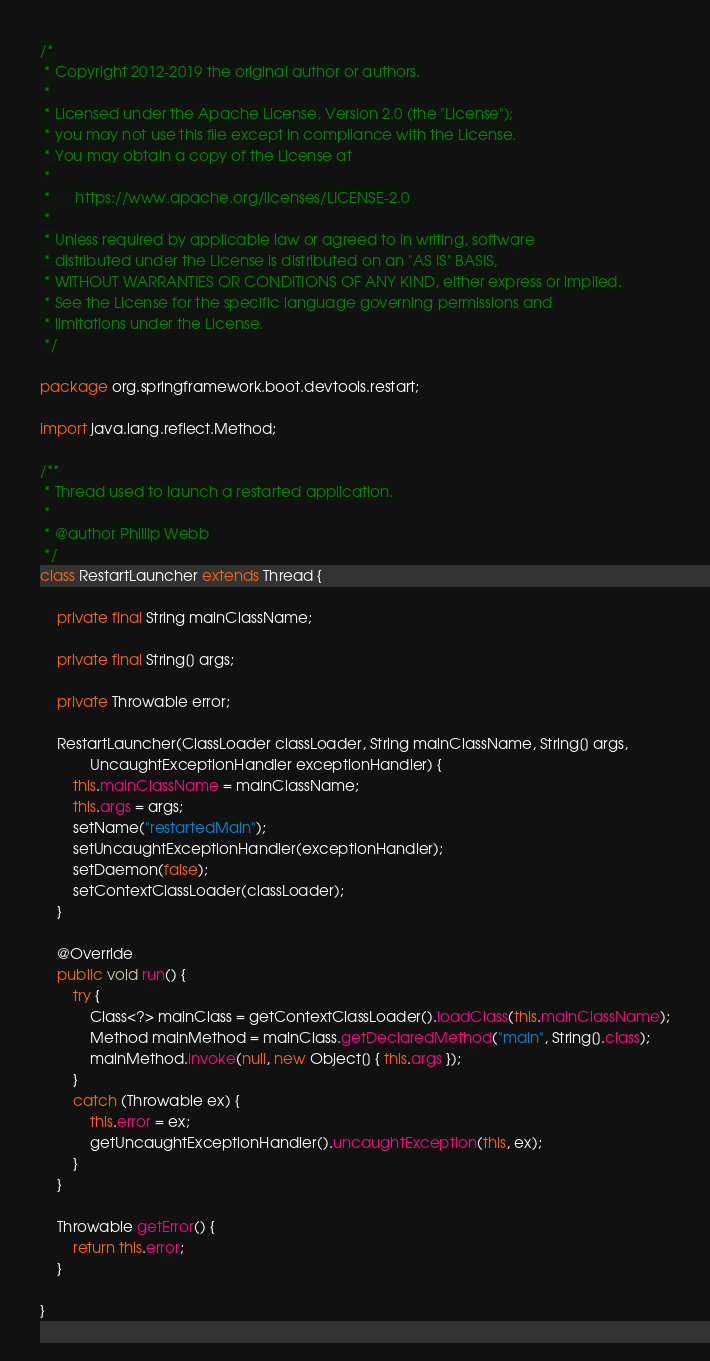<code> <loc_0><loc_0><loc_500><loc_500><_Java_>/*
 * Copyright 2012-2019 the original author or authors.
 *
 * Licensed under the Apache License, Version 2.0 (the "License");
 * you may not use this file except in compliance with the License.
 * You may obtain a copy of the License at
 *
 *      https://www.apache.org/licenses/LICENSE-2.0
 *
 * Unless required by applicable law or agreed to in writing, software
 * distributed under the License is distributed on an "AS IS" BASIS,
 * WITHOUT WARRANTIES OR CONDITIONS OF ANY KIND, either express or implied.
 * See the License for the specific language governing permissions and
 * limitations under the License.
 */

package org.springframework.boot.devtools.restart;

import java.lang.reflect.Method;

/**
 * Thread used to launch a restarted application.
 *
 * @author Phillip Webb
 */
class RestartLauncher extends Thread {

	private final String mainClassName;

	private final String[] args;

	private Throwable error;

	RestartLauncher(ClassLoader classLoader, String mainClassName, String[] args,
			UncaughtExceptionHandler exceptionHandler) {
		this.mainClassName = mainClassName;
		this.args = args;
		setName("restartedMain");
		setUncaughtExceptionHandler(exceptionHandler);
		setDaemon(false);
		setContextClassLoader(classLoader);
	}

	@Override
	public void run() {
		try {
			Class<?> mainClass = getContextClassLoader().loadClass(this.mainClassName);
			Method mainMethod = mainClass.getDeclaredMethod("main", String[].class);
			mainMethod.invoke(null, new Object[] { this.args });
		}
		catch (Throwable ex) {
			this.error = ex;
			getUncaughtExceptionHandler().uncaughtException(this, ex);
		}
	}

	Throwable getError() {
		return this.error;
	}

}
</code> 